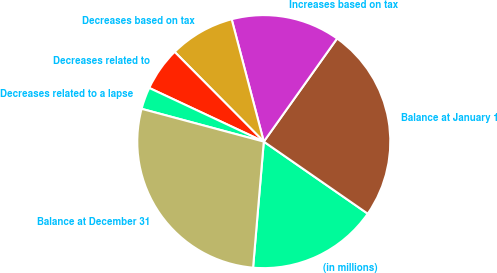Convert chart. <chart><loc_0><loc_0><loc_500><loc_500><pie_chart><fcel>(in millions)<fcel>Balance at January 1<fcel>Increases based on tax<fcel>Decreases based on tax<fcel>Decreases related to<fcel>Decreases related to a lapse<fcel>Balance at December 31<nl><fcel>16.7%<fcel>24.81%<fcel>13.92%<fcel>8.36%<fcel>5.58%<fcel>2.8%<fcel>27.82%<nl></chart> 